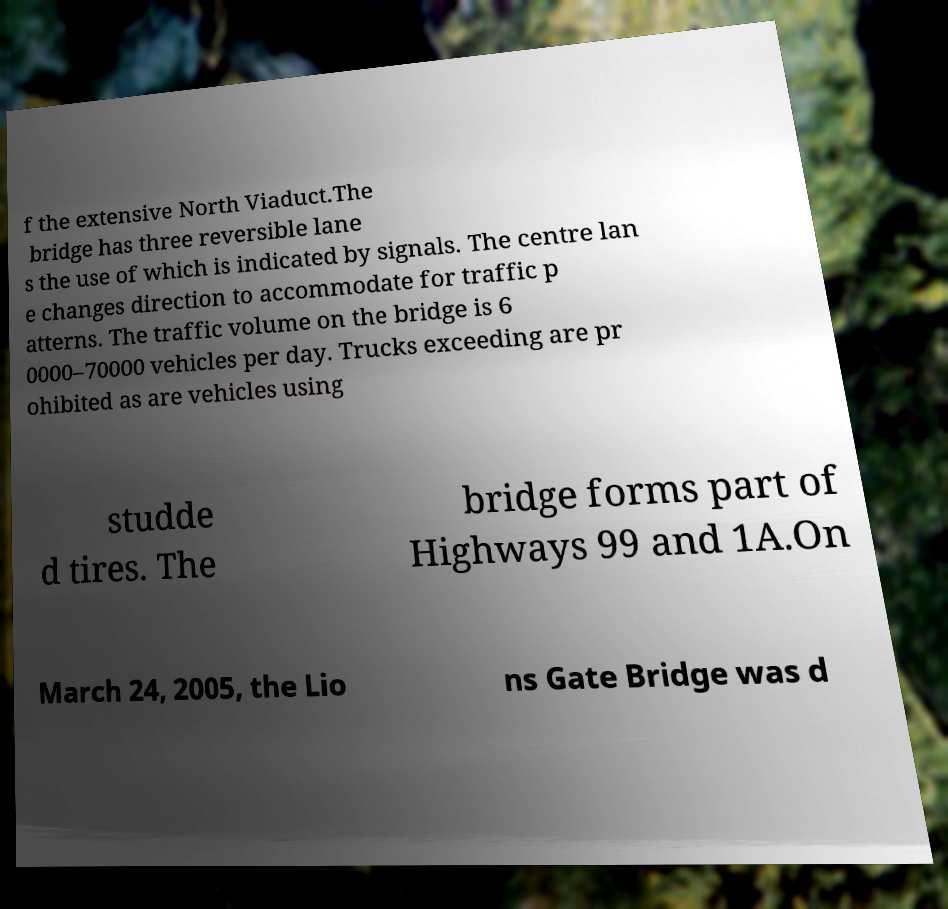Please identify and transcribe the text found in this image. f the extensive North Viaduct.The bridge has three reversible lane s the use of which is indicated by signals. The centre lan e changes direction to accommodate for traffic p atterns. The traffic volume on the bridge is 6 0000–70000 vehicles per day. Trucks exceeding are pr ohibited as are vehicles using studde d tires. The bridge forms part of Highways 99 and 1A.On March 24, 2005, the Lio ns Gate Bridge was d 